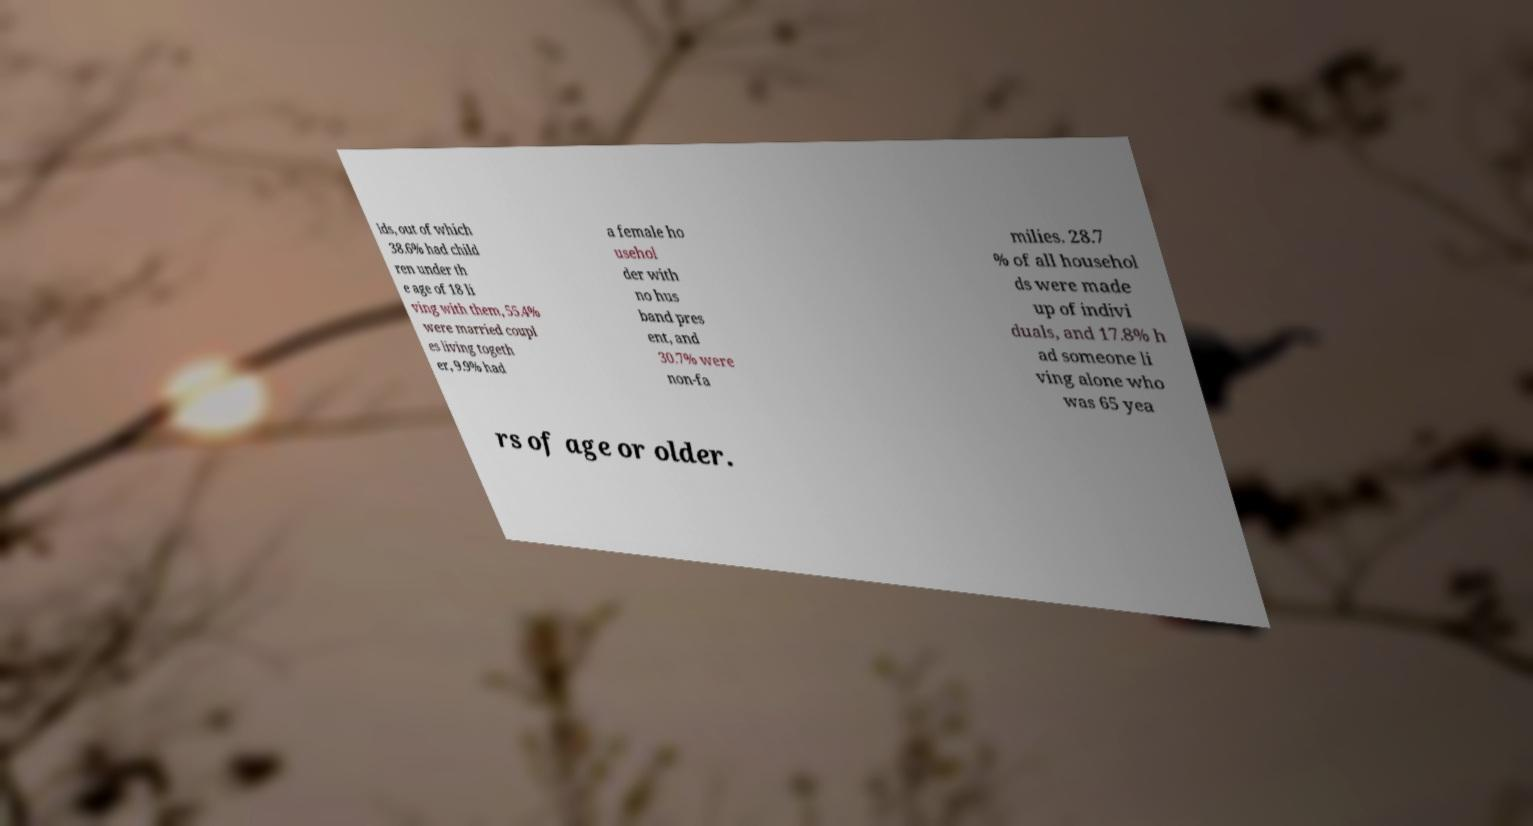Please identify and transcribe the text found in this image. lds, out of which 38.6% had child ren under th e age of 18 li ving with them, 55.4% were married coupl es living togeth er, 9.9% had a female ho usehol der with no hus band pres ent, and 30.7% were non-fa milies. 28.7 % of all househol ds were made up of indivi duals, and 17.8% h ad someone li ving alone who was 65 yea rs of age or older. 